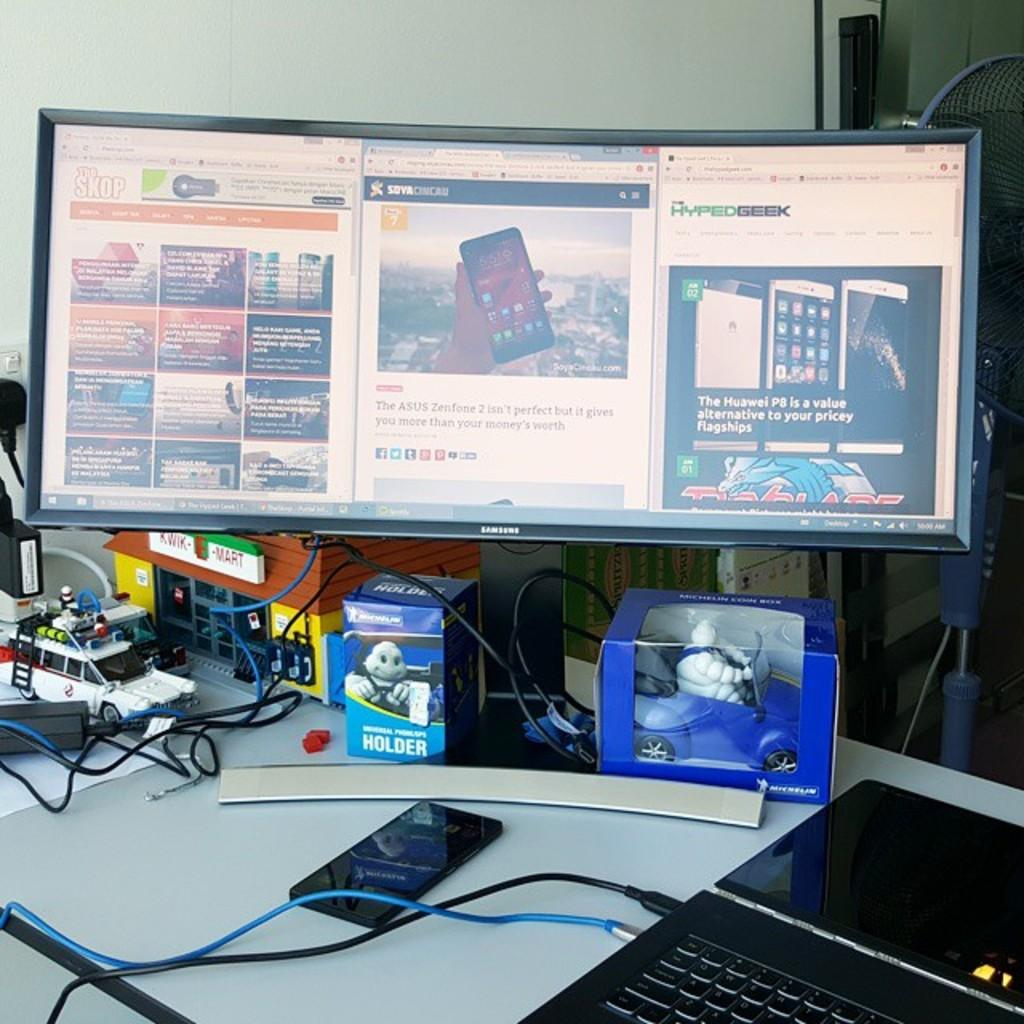<image>
Give a short and clear explanation of the subsequent image. laptop, phone, toys and a large samsung monitor with pages open for the skop, soya cincau, and hyped geek 